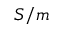Convert formula to latex. <formula><loc_0><loc_0><loc_500><loc_500>S / m</formula> 